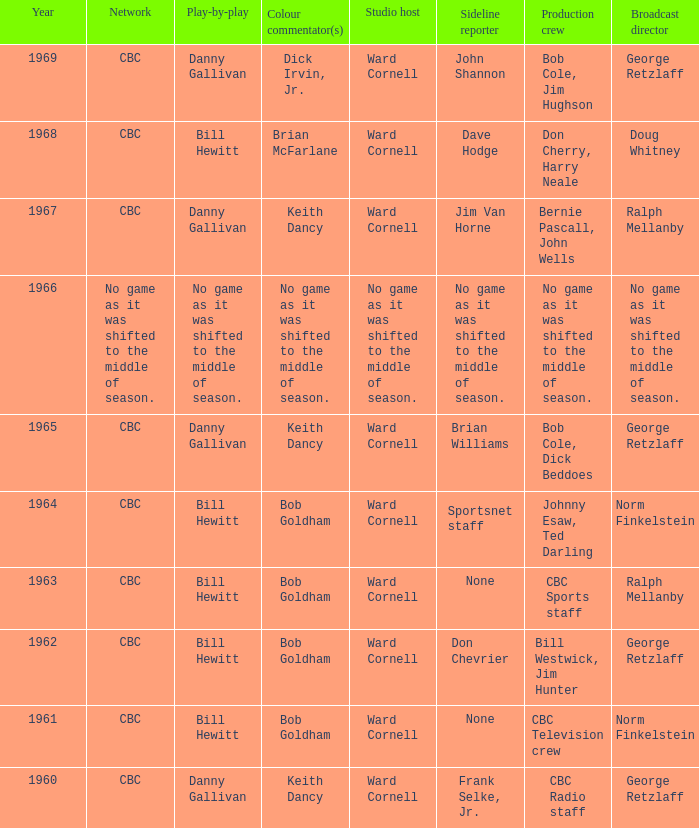Were the color commentators who worked with Bill Hewitt doing the play-by-play? Brian McFarlane, Bob Goldham, Bob Goldham, Bob Goldham, Bob Goldham. 